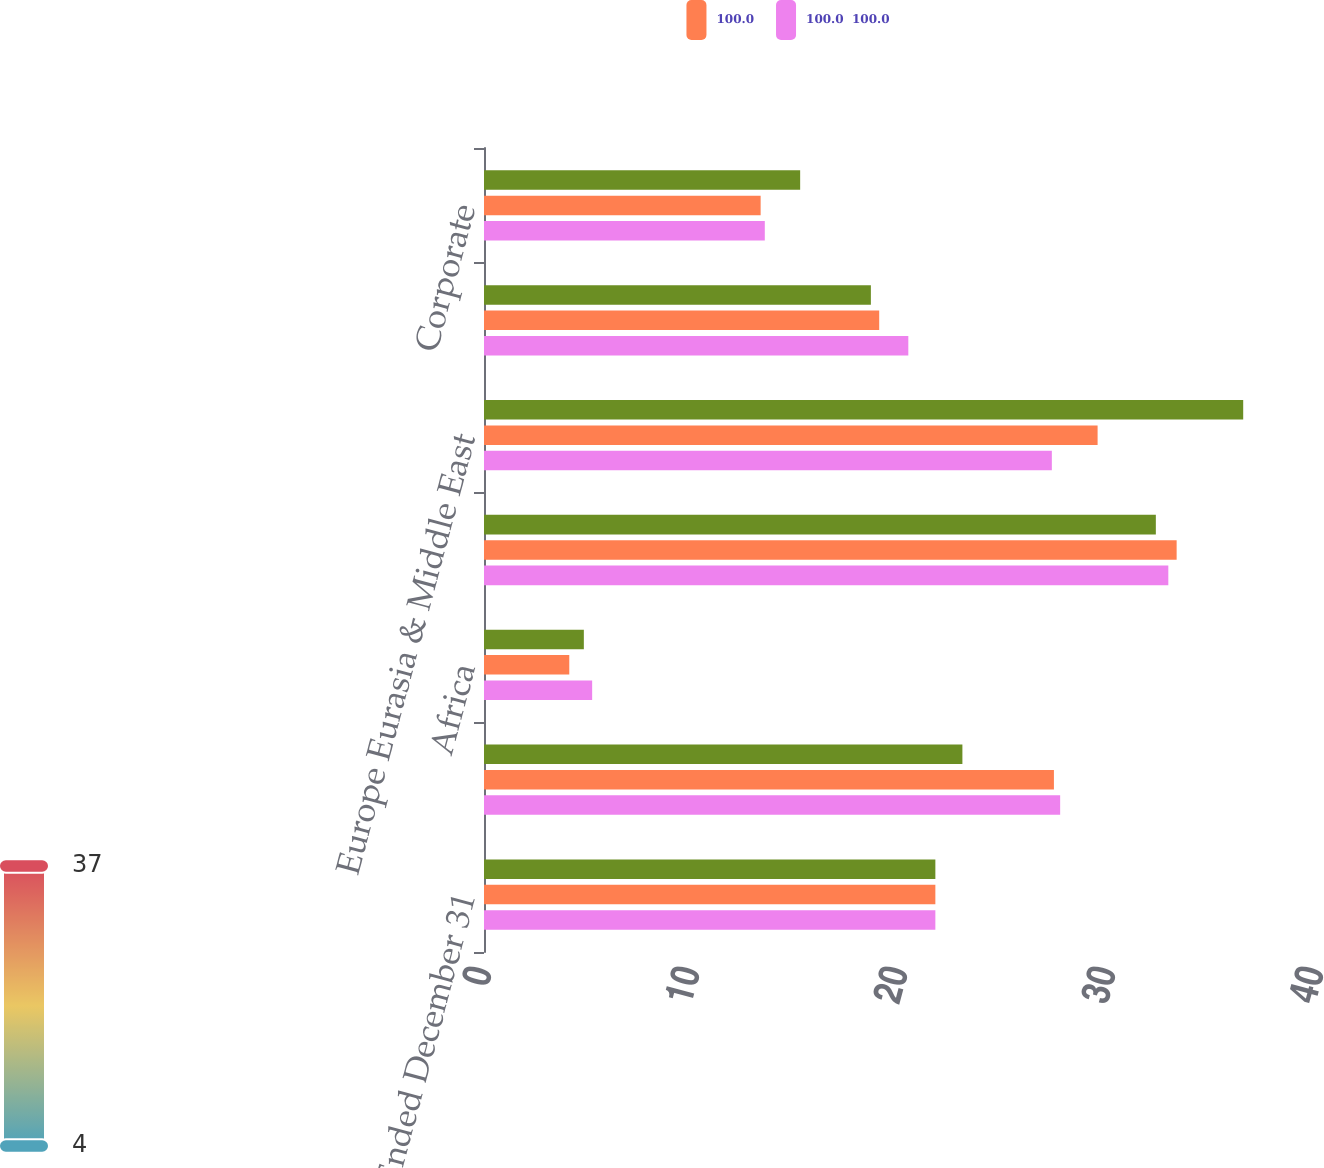Convert chart. <chart><loc_0><loc_0><loc_500><loc_500><stacked_bar_chart><ecel><fcel>Year Ended December 31<fcel>North America<fcel>Africa<fcel>Asia<fcel>Europe Eurasia & Middle East<fcel>Latin America<fcel>Corporate<nl><fcel>nan<fcel>21.7<fcel>23<fcel>4.8<fcel>32.3<fcel>36.5<fcel>18.6<fcel>15.2<nl><fcel>100.0<fcel>21.7<fcel>27.4<fcel>4.1<fcel>33.3<fcel>29.5<fcel>19<fcel>13.3<nl><fcel>100.0  100.0<fcel>21.7<fcel>27.7<fcel>5.2<fcel>32.9<fcel>27.3<fcel>20.4<fcel>13.5<nl></chart> 